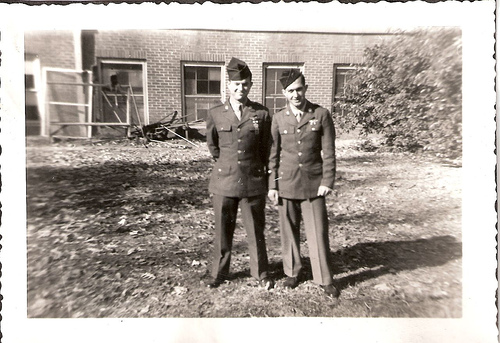<image>
Is the man behind the man? No. The man is not behind the man. From this viewpoint, the man appears to be positioned elsewhere in the scene. 